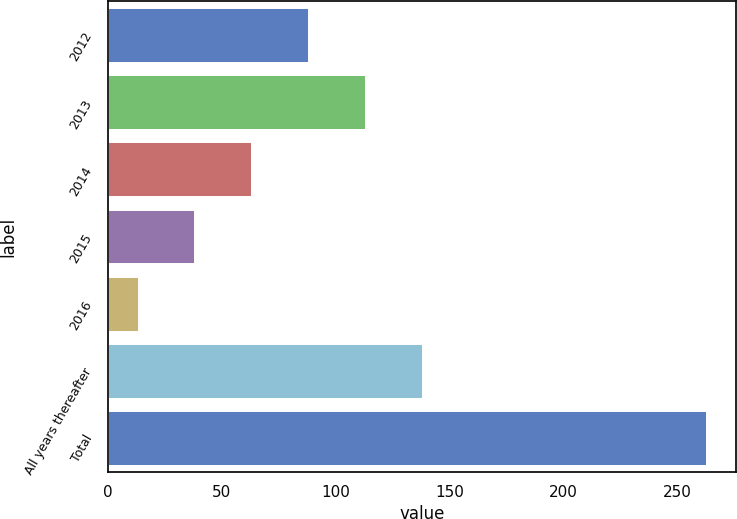<chart> <loc_0><loc_0><loc_500><loc_500><bar_chart><fcel>2012<fcel>2013<fcel>2014<fcel>2015<fcel>2016<fcel>All years thereafter<fcel>Total<nl><fcel>88<fcel>113<fcel>63<fcel>38<fcel>13<fcel>138<fcel>263<nl></chart> 